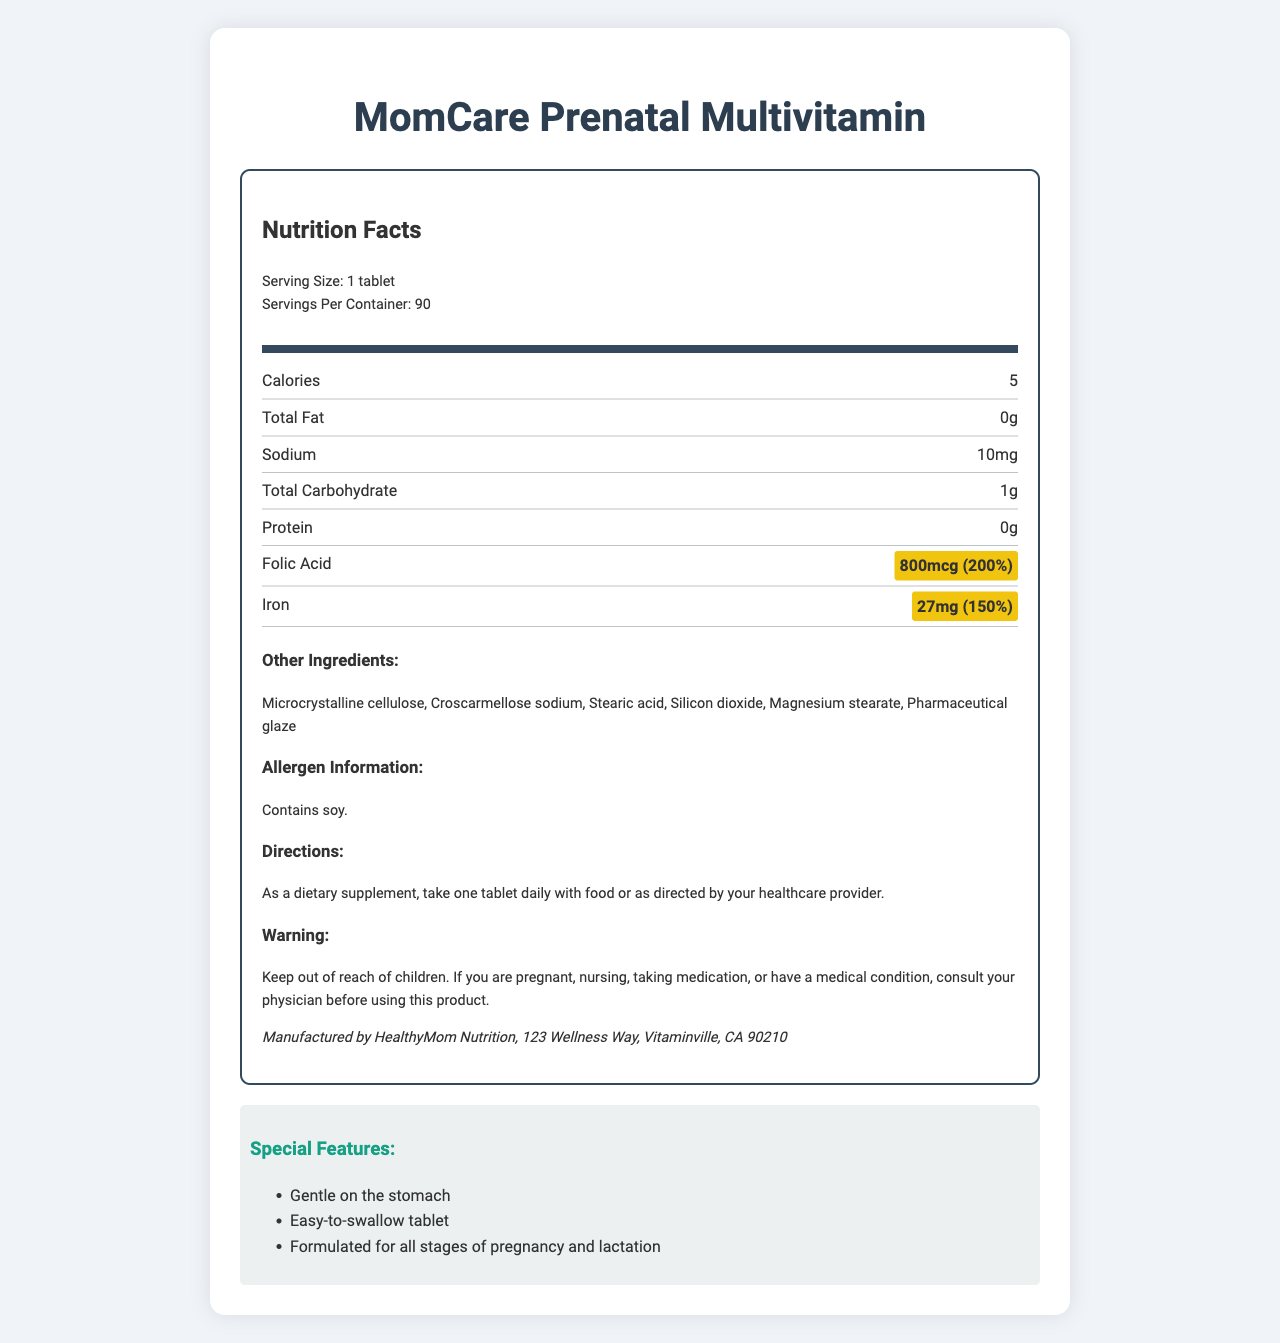what is the product name? The product name is clearly labeled at the top of the document.
Answer: MomCare Prenatal Multivitamin what is the serving size for this product? The nutrition facts indicate that the serving size is 1 tablet.
Answer: 1 tablet how many servings are in each container? The document states that there are 90 servings per container.
Answer: 90 what is the amount of folic acid per serving? The nutrition facts label highlights that each serving contains 800mcg of folic acid.
Answer: 800mcg what percentage of the daily value of iron is provided? The amount of iron per serving is highlighted as 27mg, which is 150% of the daily value.
Answer: 150% what are the special features of the MomCare Prenatal Multivitamin? The document lists these special features under the section titled "Special Features".
Answer: Gentle on the stomach, Easy-to-swallow tablet, Formulated for all stages of pregnancy and lactation what is the recommended daily dosage? The directions put forth in the document suggest taking one tablet daily with food or as directed by your healthcare provider.
Answer: One tablet daily with food or as directed by your healthcare provider which of the following nutrients has the highest amount per serving? A. Vitamin A B. Vitamin C C. Vitamin E D. Calcium Vitamin C is listed as 85mg while the others are lower in mg or mcg amounts.
Answer: B which ingredient is not listed among the other ingredients? 1. Microcrystalline cellulose 2. Lactose 3. Silicon dioxide 4. Stearic acid Lactose is not listed among the other ingredients.
Answer: 2 does the document indicate the product contains any allergens? The allergen information section mentions that the product contains soy.
Answer: Yes is this product suitable for those who are pregnant and nursing? The warning suggests consulting your physician, and the special features mention it’s formulated for all stages of pregnancy and lactation.
Answer: Yes how should you store this product? The document does not provide any storage instructions.
Answer: Not specified summarize the main idea of the document. The document breaks down the nutritional content, how to use the product safely, and what sets it apart from other prenatal vitamins, focusing on essential nutrients like folic acid and iron that are vital during pregnancy.
Answer: The document provides detailed nutrition facts for MomCare Prenatal Multivitamin, including serving size, nutrient content per serving, special features, directions for use, and allergen information, highlighting the importance of folic acid and iron content in the product. 